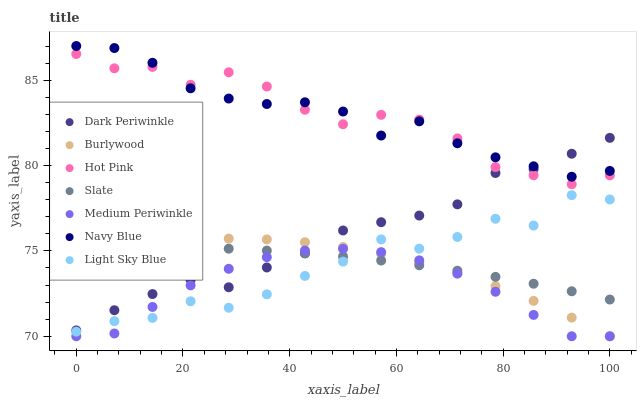Does Medium Periwinkle have the minimum area under the curve?
Answer yes or no. Yes. Does Navy Blue have the maximum area under the curve?
Answer yes or no. Yes. Does Slate have the minimum area under the curve?
Answer yes or no. No. Does Slate have the maximum area under the curve?
Answer yes or no. No. Is Slate the smoothest?
Answer yes or no. Yes. Is Light Sky Blue the roughest?
Answer yes or no. Yes. Is Navy Blue the smoothest?
Answer yes or no. No. Is Navy Blue the roughest?
Answer yes or no. No. Does Burlywood have the lowest value?
Answer yes or no. Yes. Does Slate have the lowest value?
Answer yes or no. No. Does Navy Blue have the highest value?
Answer yes or no. Yes. Does Slate have the highest value?
Answer yes or no. No. Is Medium Periwinkle less than Navy Blue?
Answer yes or no. Yes. Is Navy Blue greater than Light Sky Blue?
Answer yes or no. Yes. Does Hot Pink intersect Navy Blue?
Answer yes or no. Yes. Is Hot Pink less than Navy Blue?
Answer yes or no. No. Is Hot Pink greater than Navy Blue?
Answer yes or no. No. Does Medium Periwinkle intersect Navy Blue?
Answer yes or no. No. 